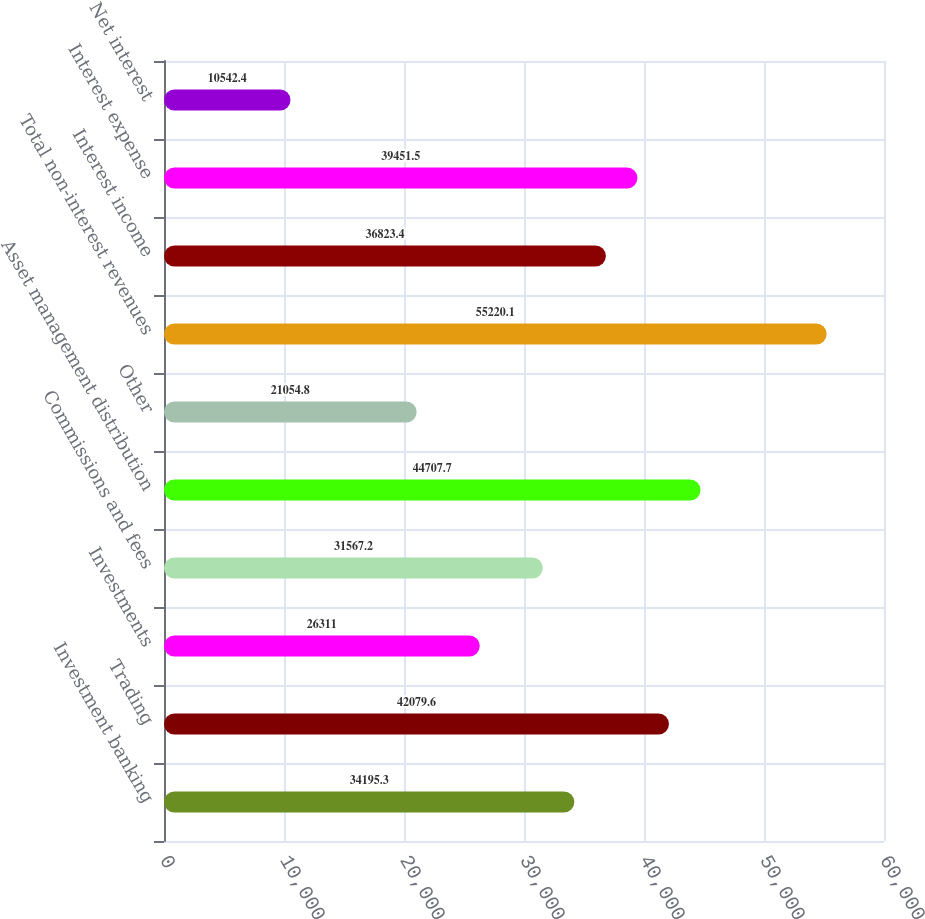<chart> <loc_0><loc_0><loc_500><loc_500><bar_chart><fcel>Investment banking<fcel>Trading<fcel>Investments<fcel>Commissions and fees<fcel>Asset management distribution<fcel>Other<fcel>Total non-interest revenues<fcel>Interest income<fcel>Interest expense<fcel>Net interest<nl><fcel>34195.3<fcel>42079.6<fcel>26311<fcel>31567.2<fcel>44707.7<fcel>21054.8<fcel>55220.1<fcel>36823.4<fcel>39451.5<fcel>10542.4<nl></chart> 